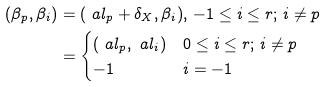<formula> <loc_0><loc_0><loc_500><loc_500>( \beta _ { p } , \beta _ { i } ) & = ( \ a l _ { p } + \delta _ { X } , \beta _ { i } ) , \, - 1 \leq i \leq r ; \, i \neq p \\ & = \begin{cases} ( \ a l _ { p } , \ a l _ { i } ) & 0 \leq i \leq r ; \, i \neq p \\ - 1 & i = - 1 \end{cases}</formula> 